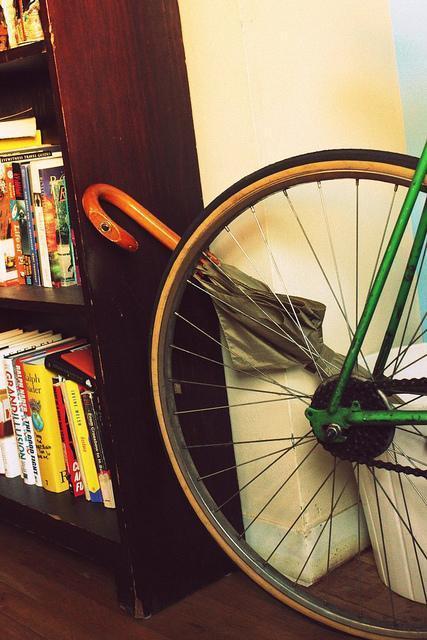How many books can you see?
Give a very brief answer. 3. 